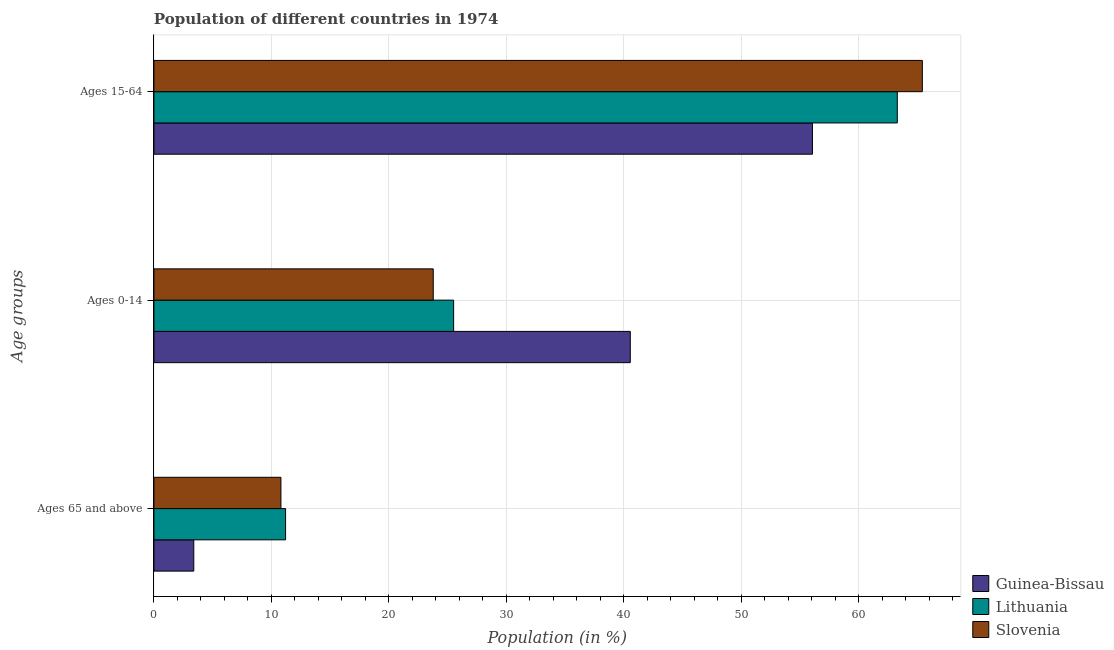How many different coloured bars are there?
Offer a very short reply. 3. Are the number of bars on each tick of the Y-axis equal?
Make the answer very short. Yes. How many bars are there on the 1st tick from the top?
Make the answer very short. 3. What is the label of the 1st group of bars from the top?
Ensure brevity in your answer.  Ages 15-64. What is the percentage of population within the age-group of 65 and above in Lithuania?
Give a very brief answer. 11.21. Across all countries, what is the maximum percentage of population within the age-group of 65 and above?
Keep it short and to the point. 11.21. Across all countries, what is the minimum percentage of population within the age-group of 65 and above?
Make the answer very short. 3.39. In which country was the percentage of population within the age-group 0-14 maximum?
Offer a terse response. Guinea-Bissau. In which country was the percentage of population within the age-group 0-14 minimum?
Offer a terse response. Slovenia. What is the total percentage of population within the age-group of 65 and above in the graph?
Keep it short and to the point. 25.41. What is the difference between the percentage of population within the age-group 0-14 in Guinea-Bissau and that in Lithuania?
Ensure brevity in your answer.  15.04. What is the difference between the percentage of population within the age-group 15-64 in Lithuania and the percentage of population within the age-group of 65 and above in Slovenia?
Your response must be concise. 52.47. What is the average percentage of population within the age-group 0-14 per country?
Make the answer very short. 29.95. What is the difference between the percentage of population within the age-group of 65 and above and percentage of population within the age-group 0-14 in Lithuania?
Give a very brief answer. -14.31. What is the ratio of the percentage of population within the age-group 15-64 in Lithuania to that in Slovenia?
Ensure brevity in your answer.  0.97. Is the percentage of population within the age-group 0-14 in Lithuania less than that in Guinea-Bissau?
Offer a very short reply. Yes. What is the difference between the highest and the second highest percentage of population within the age-group of 65 and above?
Give a very brief answer. 0.4. What is the difference between the highest and the lowest percentage of population within the age-group 0-14?
Provide a succinct answer. 16.77. Is the sum of the percentage of population within the age-group 0-14 in Slovenia and Lithuania greater than the maximum percentage of population within the age-group of 65 and above across all countries?
Your answer should be very brief. Yes. What does the 1st bar from the top in Ages 15-64 represents?
Your response must be concise. Slovenia. What does the 2nd bar from the bottom in Ages 0-14 represents?
Keep it short and to the point. Lithuania. Is it the case that in every country, the sum of the percentage of population within the age-group of 65 and above and percentage of population within the age-group 0-14 is greater than the percentage of population within the age-group 15-64?
Give a very brief answer. No. Are all the bars in the graph horizontal?
Your response must be concise. Yes. Does the graph contain any zero values?
Keep it short and to the point. No. Does the graph contain grids?
Give a very brief answer. Yes. Where does the legend appear in the graph?
Provide a short and direct response. Bottom right. What is the title of the graph?
Provide a succinct answer. Population of different countries in 1974. What is the label or title of the X-axis?
Keep it short and to the point. Population (in %). What is the label or title of the Y-axis?
Your response must be concise. Age groups. What is the Population (in %) of Guinea-Bissau in Ages 65 and above?
Your answer should be very brief. 3.39. What is the Population (in %) in Lithuania in Ages 65 and above?
Provide a short and direct response. 11.21. What is the Population (in %) of Slovenia in Ages 65 and above?
Offer a very short reply. 10.81. What is the Population (in %) in Guinea-Bissau in Ages 0-14?
Your answer should be compact. 40.55. What is the Population (in %) of Lithuania in Ages 0-14?
Your answer should be compact. 25.51. What is the Population (in %) in Slovenia in Ages 0-14?
Your answer should be compact. 23.78. What is the Population (in %) in Guinea-Bissau in Ages 15-64?
Your answer should be very brief. 56.06. What is the Population (in %) in Lithuania in Ages 15-64?
Give a very brief answer. 63.28. What is the Population (in %) in Slovenia in Ages 15-64?
Provide a succinct answer. 65.41. Across all Age groups, what is the maximum Population (in %) of Guinea-Bissau?
Give a very brief answer. 56.06. Across all Age groups, what is the maximum Population (in %) of Lithuania?
Ensure brevity in your answer.  63.28. Across all Age groups, what is the maximum Population (in %) in Slovenia?
Your answer should be very brief. 65.41. Across all Age groups, what is the minimum Population (in %) of Guinea-Bissau?
Your response must be concise. 3.39. Across all Age groups, what is the minimum Population (in %) of Lithuania?
Provide a succinct answer. 11.21. Across all Age groups, what is the minimum Population (in %) in Slovenia?
Offer a terse response. 10.81. What is the total Population (in %) of Guinea-Bissau in the graph?
Make the answer very short. 100. What is the total Population (in %) in Lithuania in the graph?
Give a very brief answer. 100. What is the total Population (in %) of Slovenia in the graph?
Your response must be concise. 100. What is the difference between the Population (in %) of Guinea-Bissau in Ages 65 and above and that in Ages 0-14?
Your answer should be compact. -37.16. What is the difference between the Population (in %) of Lithuania in Ages 65 and above and that in Ages 0-14?
Ensure brevity in your answer.  -14.31. What is the difference between the Population (in %) in Slovenia in Ages 65 and above and that in Ages 0-14?
Give a very brief answer. -12.97. What is the difference between the Population (in %) in Guinea-Bissau in Ages 65 and above and that in Ages 15-64?
Ensure brevity in your answer.  -52.66. What is the difference between the Population (in %) in Lithuania in Ages 65 and above and that in Ages 15-64?
Provide a succinct answer. -52.07. What is the difference between the Population (in %) of Slovenia in Ages 65 and above and that in Ages 15-64?
Offer a very short reply. -54.6. What is the difference between the Population (in %) in Guinea-Bissau in Ages 0-14 and that in Ages 15-64?
Offer a terse response. -15.51. What is the difference between the Population (in %) in Lithuania in Ages 0-14 and that in Ages 15-64?
Give a very brief answer. -37.77. What is the difference between the Population (in %) of Slovenia in Ages 0-14 and that in Ages 15-64?
Your response must be concise. -41.63. What is the difference between the Population (in %) of Guinea-Bissau in Ages 65 and above and the Population (in %) of Lithuania in Ages 0-14?
Provide a short and direct response. -22.12. What is the difference between the Population (in %) in Guinea-Bissau in Ages 65 and above and the Population (in %) in Slovenia in Ages 0-14?
Ensure brevity in your answer.  -20.38. What is the difference between the Population (in %) in Lithuania in Ages 65 and above and the Population (in %) in Slovenia in Ages 0-14?
Provide a short and direct response. -12.57. What is the difference between the Population (in %) in Guinea-Bissau in Ages 65 and above and the Population (in %) in Lithuania in Ages 15-64?
Ensure brevity in your answer.  -59.89. What is the difference between the Population (in %) of Guinea-Bissau in Ages 65 and above and the Population (in %) of Slovenia in Ages 15-64?
Keep it short and to the point. -62.02. What is the difference between the Population (in %) of Lithuania in Ages 65 and above and the Population (in %) of Slovenia in Ages 15-64?
Ensure brevity in your answer.  -54.2. What is the difference between the Population (in %) in Guinea-Bissau in Ages 0-14 and the Population (in %) in Lithuania in Ages 15-64?
Offer a terse response. -22.73. What is the difference between the Population (in %) of Guinea-Bissau in Ages 0-14 and the Population (in %) of Slovenia in Ages 15-64?
Your answer should be compact. -24.86. What is the difference between the Population (in %) of Lithuania in Ages 0-14 and the Population (in %) of Slovenia in Ages 15-64?
Keep it short and to the point. -39.9. What is the average Population (in %) in Guinea-Bissau per Age groups?
Make the answer very short. 33.33. What is the average Population (in %) in Lithuania per Age groups?
Make the answer very short. 33.33. What is the average Population (in %) in Slovenia per Age groups?
Offer a terse response. 33.33. What is the difference between the Population (in %) of Guinea-Bissau and Population (in %) of Lithuania in Ages 65 and above?
Make the answer very short. -7.81. What is the difference between the Population (in %) of Guinea-Bissau and Population (in %) of Slovenia in Ages 65 and above?
Your answer should be compact. -7.42. What is the difference between the Population (in %) of Lithuania and Population (in %) of Slovenia in Ages 65 and above?
Your answer should be very brief. 0.4. What is the difference between the Population (in %) in Guinea-Bissau and Population (in %) in Lithuania in Ages 0-14?
Provide a succinct answer. 15.04. What is the difference between the Population (in %) of Guinea-Bissau and Population (in %) of Slovenia in Ages 0-14?
Your answer should be compact. 16.77. What is the difference between the Population (in %) in Lithuania and Population (in %) in Slovenia in Ages 0-14?
Offer a very short reply. 1.74. What is the difference between the Population (in %) in Guinea-Bissau and Population (in %) in Lithuania in Ages 15-64?
Offer a very short reply. -7.22. What is the difference between the Population (in %) in Guinea-Bissau and Population (in %) in Slovenia in Ages 15-64?
Your answer should be very brief. -9.35. What is the difference between the Population (in %) in Lithuania and Population (in %) in Slovenia in Ages 15-64?
Your response must be concise. -2.13. What is the ratio of the Population (in %) of Guinea-Bissau in Ages 65 and above to that in Ages 0-14?
Keep it short and to the point. 0.08. What is the ratio of the Population (in %) in Lithuania in Ages 65 and above to that in Ages 0-14?
Your response must be concise. 0.44. What is the ratio of the Population (in %) of Slovenia in Ages 65 and above to that in Ages 0-14?
Offer a very short reply. 0.45. What is the ratio of the Population (in %) in Guinea-Bissau in Ages 65 and above to that in Ages 15-64?
Provide a short and direct response. 0.06. What is the ratio of the Population (in %) in Lithuania in Ages 65 and above to that in Ages 15-64?
Ensure brevity in your answer.  0.18. What is the ratio of the Population (in %) in Slovenia in Ages 65 and above to that in Ages 15-64?
Your answer should be compact. 0.17. What is the ratio of the Population (in %) of Guinea-Bissau in Ages 0-14 to that in Ages 15-64?
Offer a very short reply. 0.72. What is the ratio of the Population (in %) in Lithuania in Ages 0-14 to that in Ages 15-64?
Your answer should be very brief. 0.4. What is the ratio of the Population (in %) in Slovenia in Ages 0-14 to that in Ages 15-64?
Offer a very short reply. 0.36. What is the difference between the highest and the second highest Population (in %) of Guinea-Bissau?
Offer a terse response. 15.51. What is the difference between the highest and the second highest Population (in %) of Lithuania?
Keep it short and to the point. 37.77. What is the difference between the highest and the second highest Population (in %) of Slovenia?
Give a very brief answer. 41.63. What is the difference between the highest and the lowest Population (in %) of Guinea-Bissau?
Your answer should be very brief. 52.66. What is the difference between the highest and the lowest Population (in %) in Lithuania?
Your response must be concise. 52.07. What is the difference between the highest and the lowest Population (in %) of Slovenia?
Ensure brevity in your answer.  54.6. 